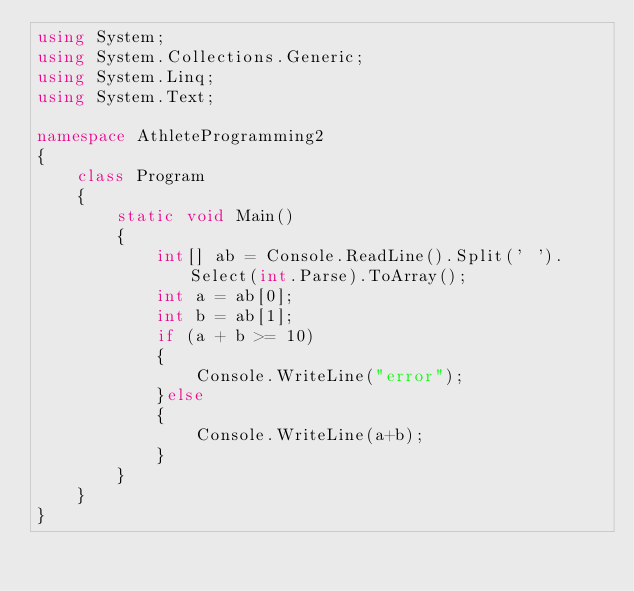Convert code to text. <code><loc_0><loc_0><loc_500><loc_500><_C#_>using System;
using System.Collections.Generic;
using System.Linq;
using System.Text;

namespace AthleteProgramming2
{
    class Program
    {
        static void Main()
        {
            int[] ab = Console.ReadLine().Split(' ').Select(int.Parse).ToArray();
            int a = ab[0];
            int b = ab[1];
            if (a + b >= 10)
            {
                Console.WriteLine("error");
            }else
            {
                Console.WriteLine(a+b);
            }
        }
    }
}
</code> 